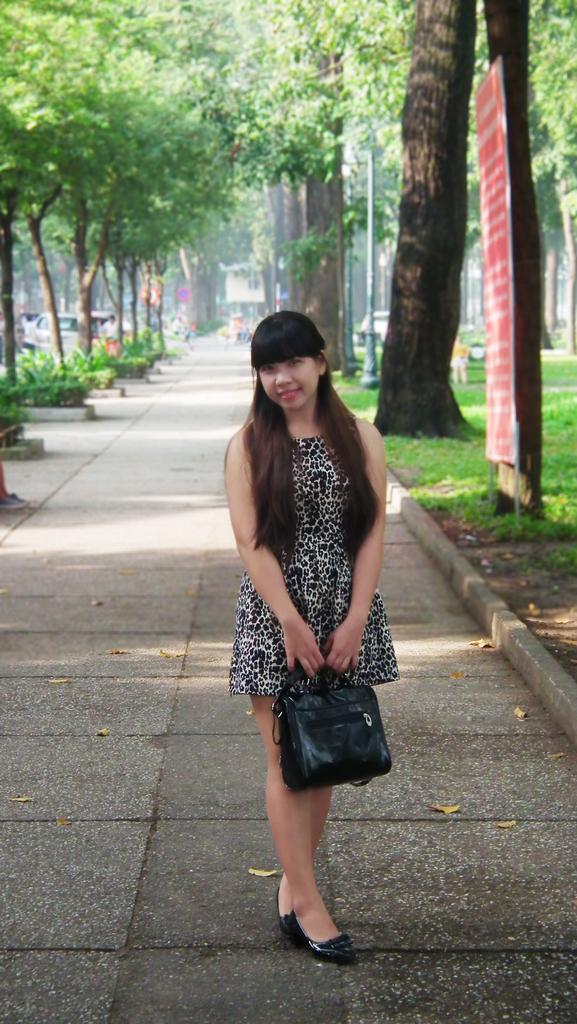Can you describe this image briefly? There is an outside view of a picture. There is a person standing at the center of this image and wearing clothes. There are some trees behind this person. This person is holding a bag with her hand. There is a banner in the top right of the image. 